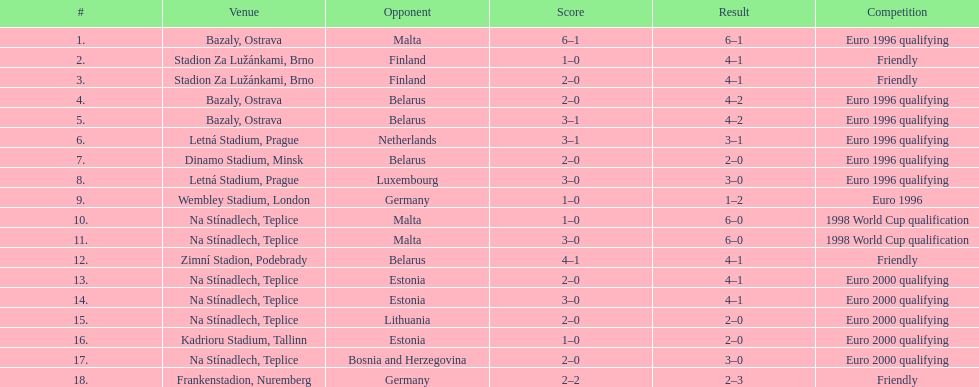What opponent is listed last on the table? Germany. Parse the table in full. {'header': ['#', 'Venue', 'Opponent', 'Score', 'Result', 'Competition'], 'rows': [['1.', 'Bazaly, Ostrava', 'Malta', '6–1', '6–1', 'Euro 1996 qualifying'], ['2.', 'Stadion Za Lužánkami, Brno', 'Finland', '1–0', '4–1', 'Friendly'], ['3.', 'Stadion Za Lužánkami, Brno', 'Finland', '2–0', '4–1', 'Friendly'], ['4.', 'Bazaly, Ostrava', 'Belarus', '2–0', '4–2', 'Euro 1996 qualifying'], ['5.', 'Bazaly, Ostrava', 'Belarus', '3–1', '4–2', 'Euro 1996 qualifying'], ['6.', 'Letná Stadium, Prague', 'Netherlands', '3–1', '3–1', 'Euro 1996 qualifying'], ['7.', 'Dinamo Stadium, Minsk', 'Belarus', '2–0', '2–0', 'Euro 1996 qualifying'], ['8.', 'Letná Stadium, Prague', 'Luxembourg', '3–0', '3–0', 'Euro 1996 qualifying'], ['9.', 'Wembley Stadium, London', 'Germany', '1–0', '1–2', 'Euro 1996'], ['10.', 'Na Stínadlech, Teplice', 'Malta', '1–0', '6–0', '1998 World Cup qualification'], ['11.', 'Na Stínadlech, Teplice', 'Malta', '3–0', '6–0', '1998 World Cup qualification'], ['12.', 'Zimní Stadion, Podebrady', 'Belarus', '4–1', '4–1', 'Friendly'], ['13.', 'Na Stínadlech, Teplice', 'Estonia', '2–0', '4–1', 'Euro 2000 qualifying'], ['14.', 'Na Stínadlech, Teplice', 'Estonia', '3–0', '4–1', 'Euro 2000 qualifying'], ['15.', 'Na Stínadlech, Teplice', 'Lithuania', '2–0', '2–0', 'Euro 2000 qualifying'], ['16.', 'Kadrioru Stadium, Tallinn', 'Estonia', '1–0', '2–0', 'Euro 2000 qualifying'], ['17.', 'Na Stínadlech, Teplice', 'Bosnia and Herzegovina', '2–0', '3–0', 'Euro 2000 qualifying'], ['18.', 'Frankenstadion, Nuremberg', 'Germany', '2–2', '2–3', 'Friendly']]} 